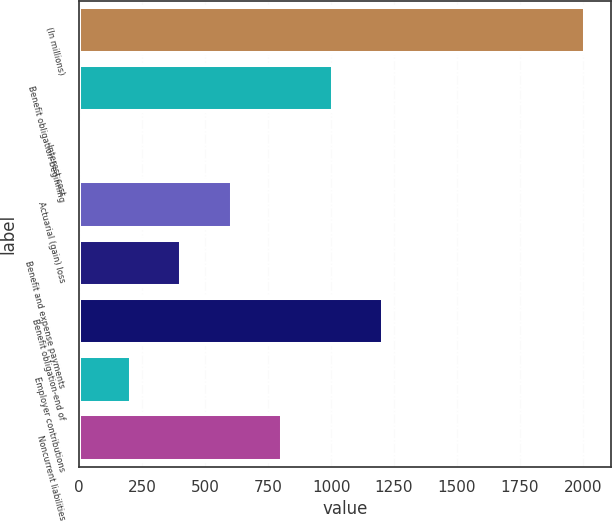<chart> <loc_0><loc_0><loc_500><loc_500><bar_chart><fcel>(In millions)<fcel>Benefit obligation-beginning<fcel>Interest cost<fcel>Actuarial (gain) loss<fcel>Benefit and expense payments<fcel>Benefit obligation-end of<fcel>Employer contributions<fcel>Noncurrent liabilities<nl><fcel>2010<fcel>1007.45<fcel>4.9<fcel>606.43<fcel>405.92<fcel>1207.96<fcel>205.41<fcel>806.94<nl></chart> 